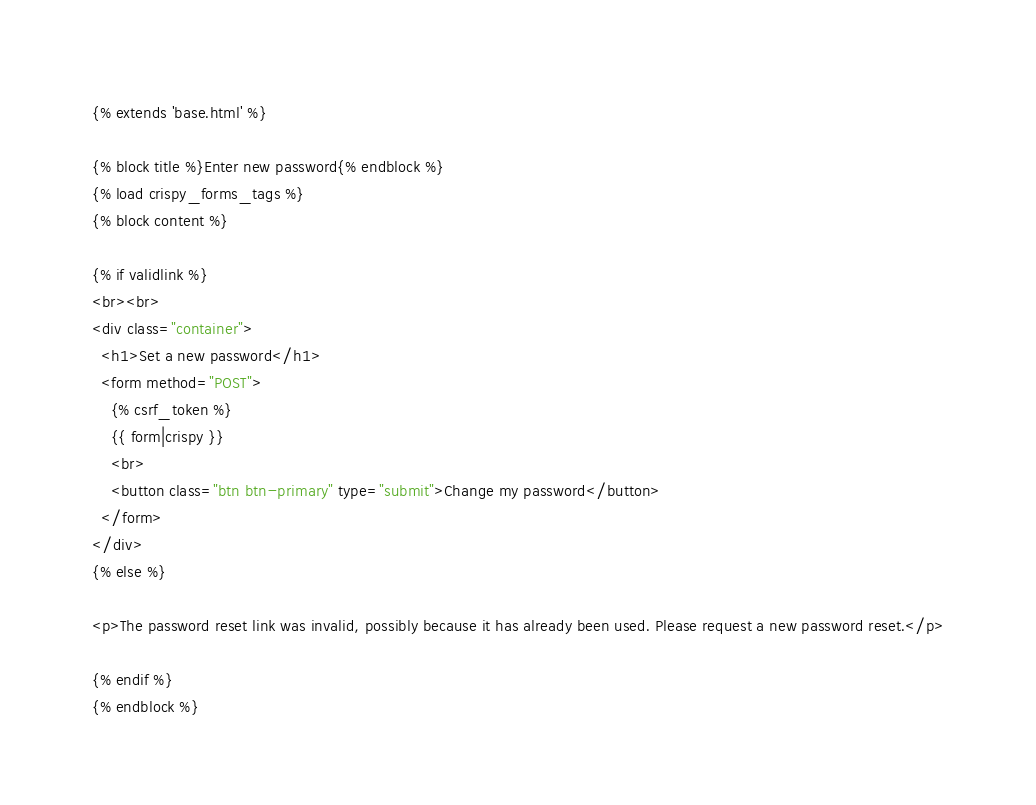Convert code to text. <code><loc_0><loc_0><loc_500><loc_500><_HTML_>{% extends 'base.html' %}

{% block title %}Enter new password{% endblock %}
{% load crispy_forms_tags %}
{% block content %}

{% if validlink %}
<br><br>
<div class="container">
  <h1>Set a new password</h1>
  <form method="POST">
    {% csrf_token %}
    {{ form|crispy }}
    <br>
    <button class="btn btn-primary" type="submit">Change my password</button>
  </form>
</div>
{% else %}

<p>The password reset link was invalid, possibly because it has already been used. Please request a new password reset.</p>

{% endif %}
{% endblock %}</code> 